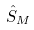Convert formula to latex. <formula><loc_0><loc_0><loc_500><loc_500>\hat { S } _ { M }</formula> 